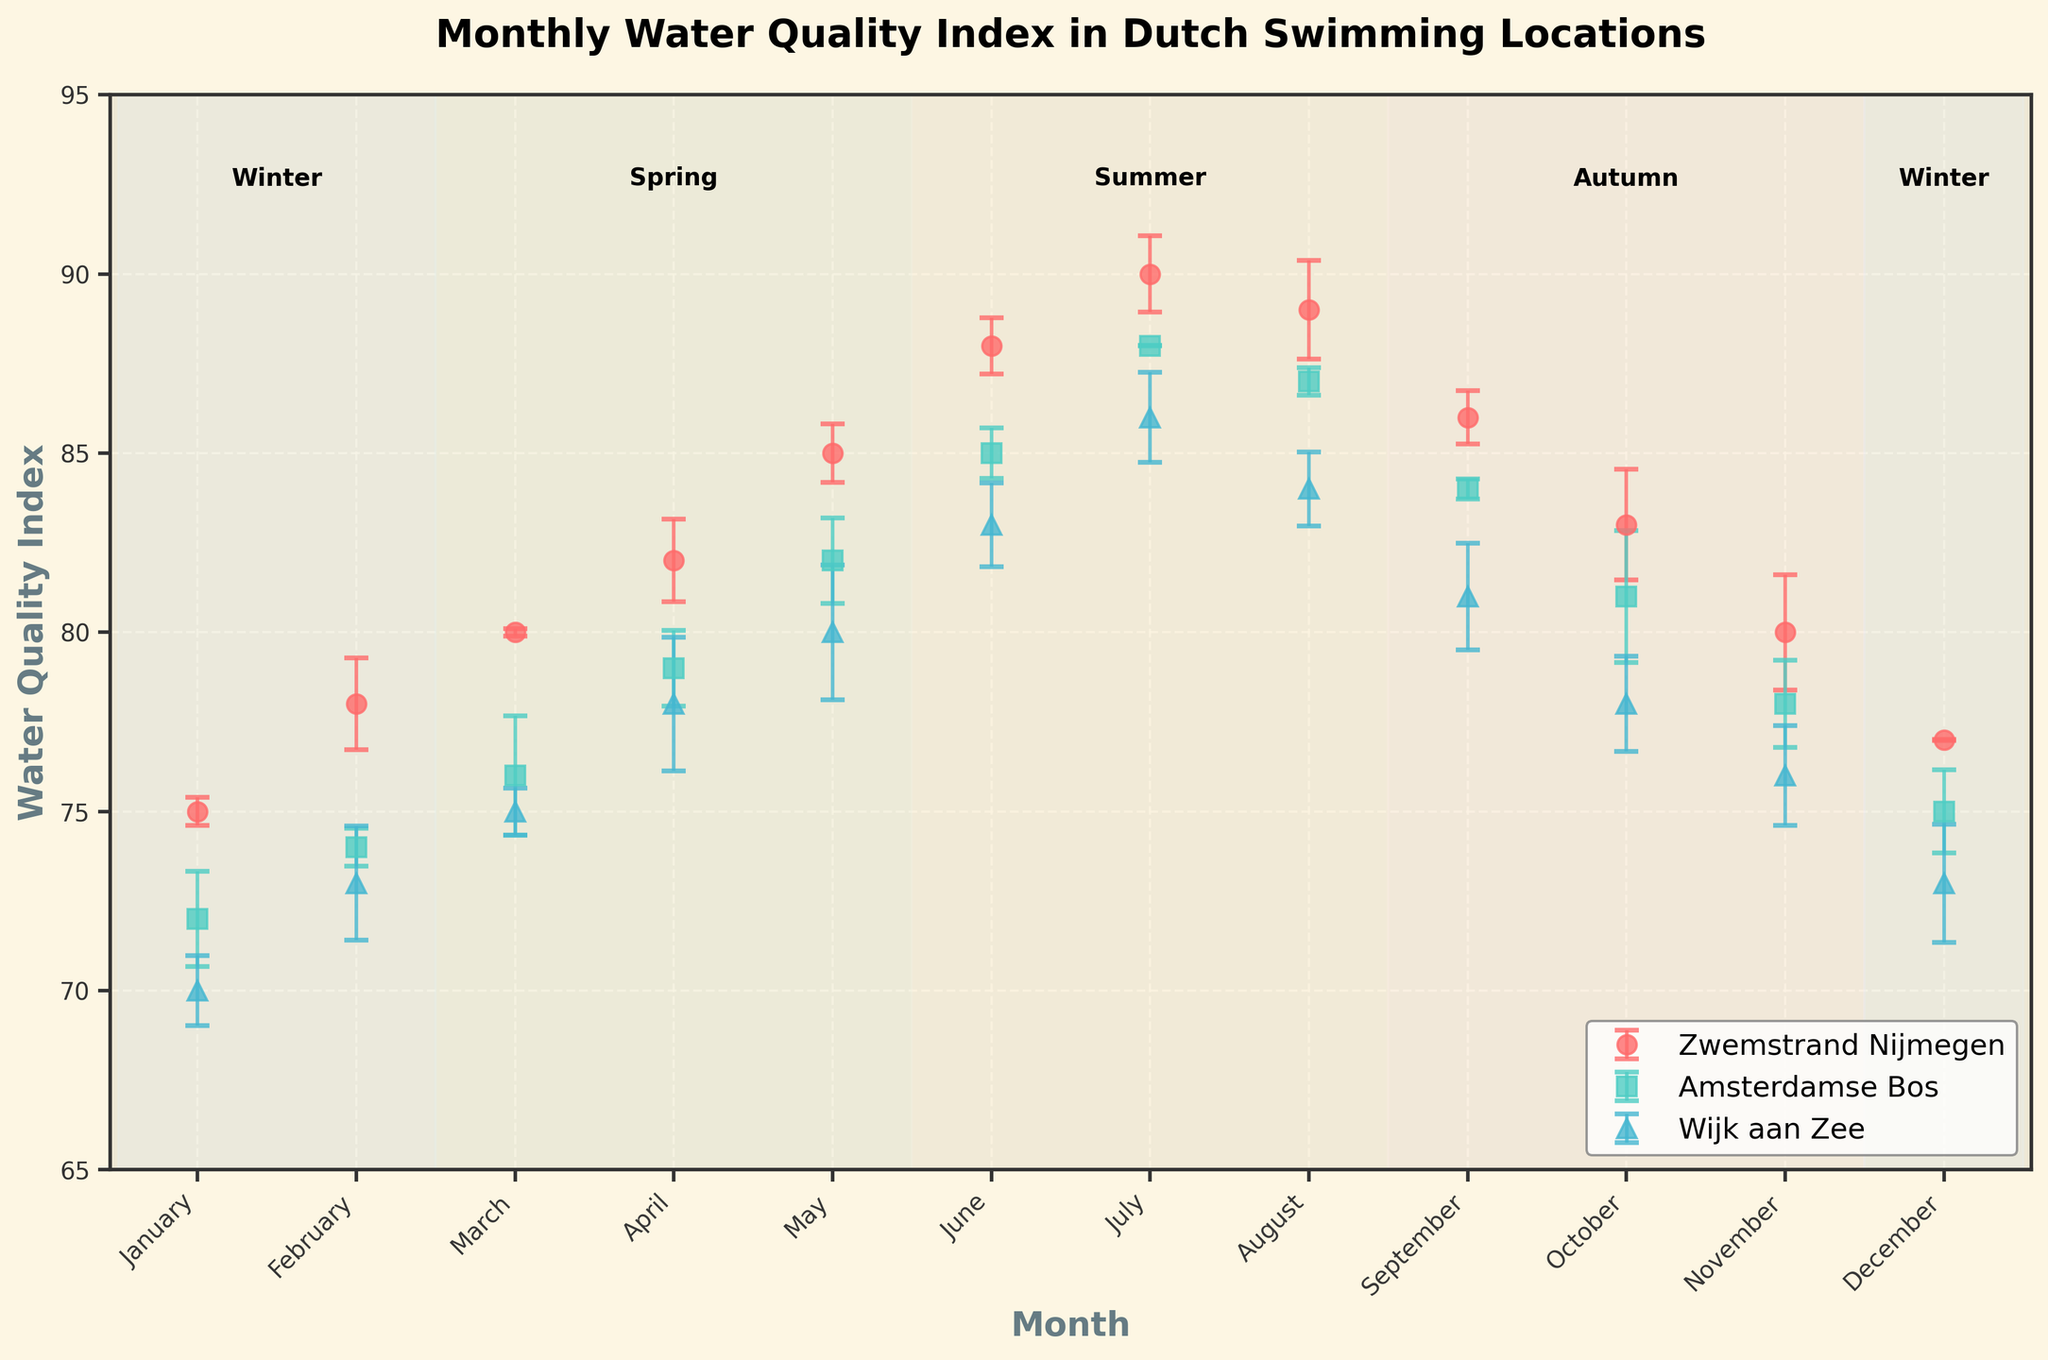What is the title of the plot? The title of the plot is displayed at the top center. It provides a brief description of what the plot is about. The title is "Monthly Water Quality Index in Dutch Swimming Locations".
Answer: Monthly Water Quality Index in Dutch Swimming Locations Which location has the highest Water Quality Index in July? In July, all three locations will have their data points shown on the plot. By comparing them, Zwemstrand Nijmegen has the highest value.
Answer: Zwemstrand Nijmegen Between which months does the Autumn season span in the plot? The seasons are marked by shaded bands on the plot. The Autumn season spans from September to November.
Answer: September to November Which month shows the most significant variability in the Water Quality Index for all locations? Variability can be judged by the length of error bars. The month with the longest error bars among all plotted months must be identified.
Answer: August How does the Water Quality Index in Zwemstrand Nijmegen change from January to December? Look at the error bars for Zwemstrand Nijmegen, marked with a specific style and color. Note how the Water Quality Index values evolve from January to December.
Answer: It increases from 75 in January to a peak of 90 in July and decreases to 77 in December What season has the highest average Water Quality Index in Amsterdamse Bos? Calculate the average value for each season by visually inspecting the respective bands and their data points, then compare these averages to find the highest.
Answer: Summer Which location shows the smallest change in Water Quality Index from Winter to Spring? Examine data points from Winter to Spring for each location. Identify the location with the least overall change between December and March.
Answer: Wijk aan Zee In which months do the Water Quality Index values for all locations peak? Identify the highest points in the plot for each location and note the corresponding months. Look for the common months across all locations.
Answer: June and July During which season does Wijk aan Zee have a consistently higher Water Quality Index compared to the other locations? Compare the data of Wijk aan Zee with other locations across each season by closely inspecting respective bands. Identify the season where Wijk aan Zee has higher values throughout.
Answer: Summer 